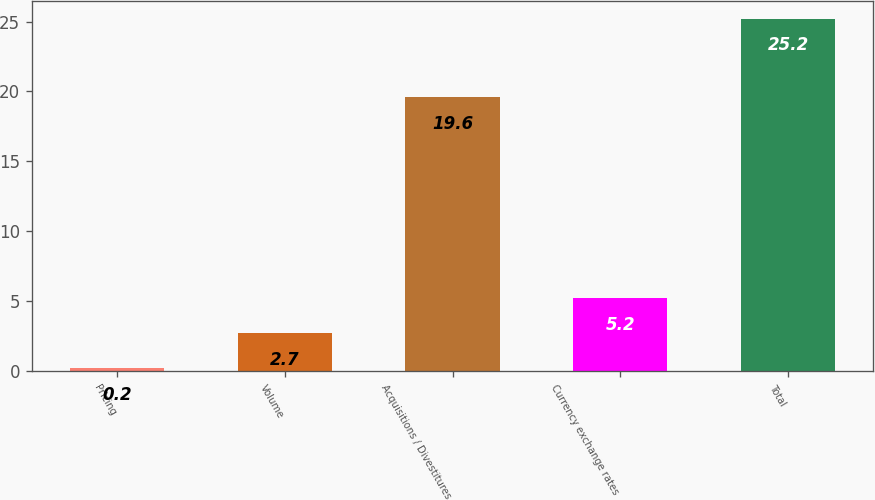<chart> <loc_0><loc_0><loc_500><loc_500><bar_chart><fcel>Pricing<fcel>Volume<fcel>Acquisitions / Divestitures<fcel>Currency exchange rates<fcel>Total<nl><fcel>0.2<fcel>2.7<fcel>19.6<fcel>5.2<fcel>25.2<nl></chart> 